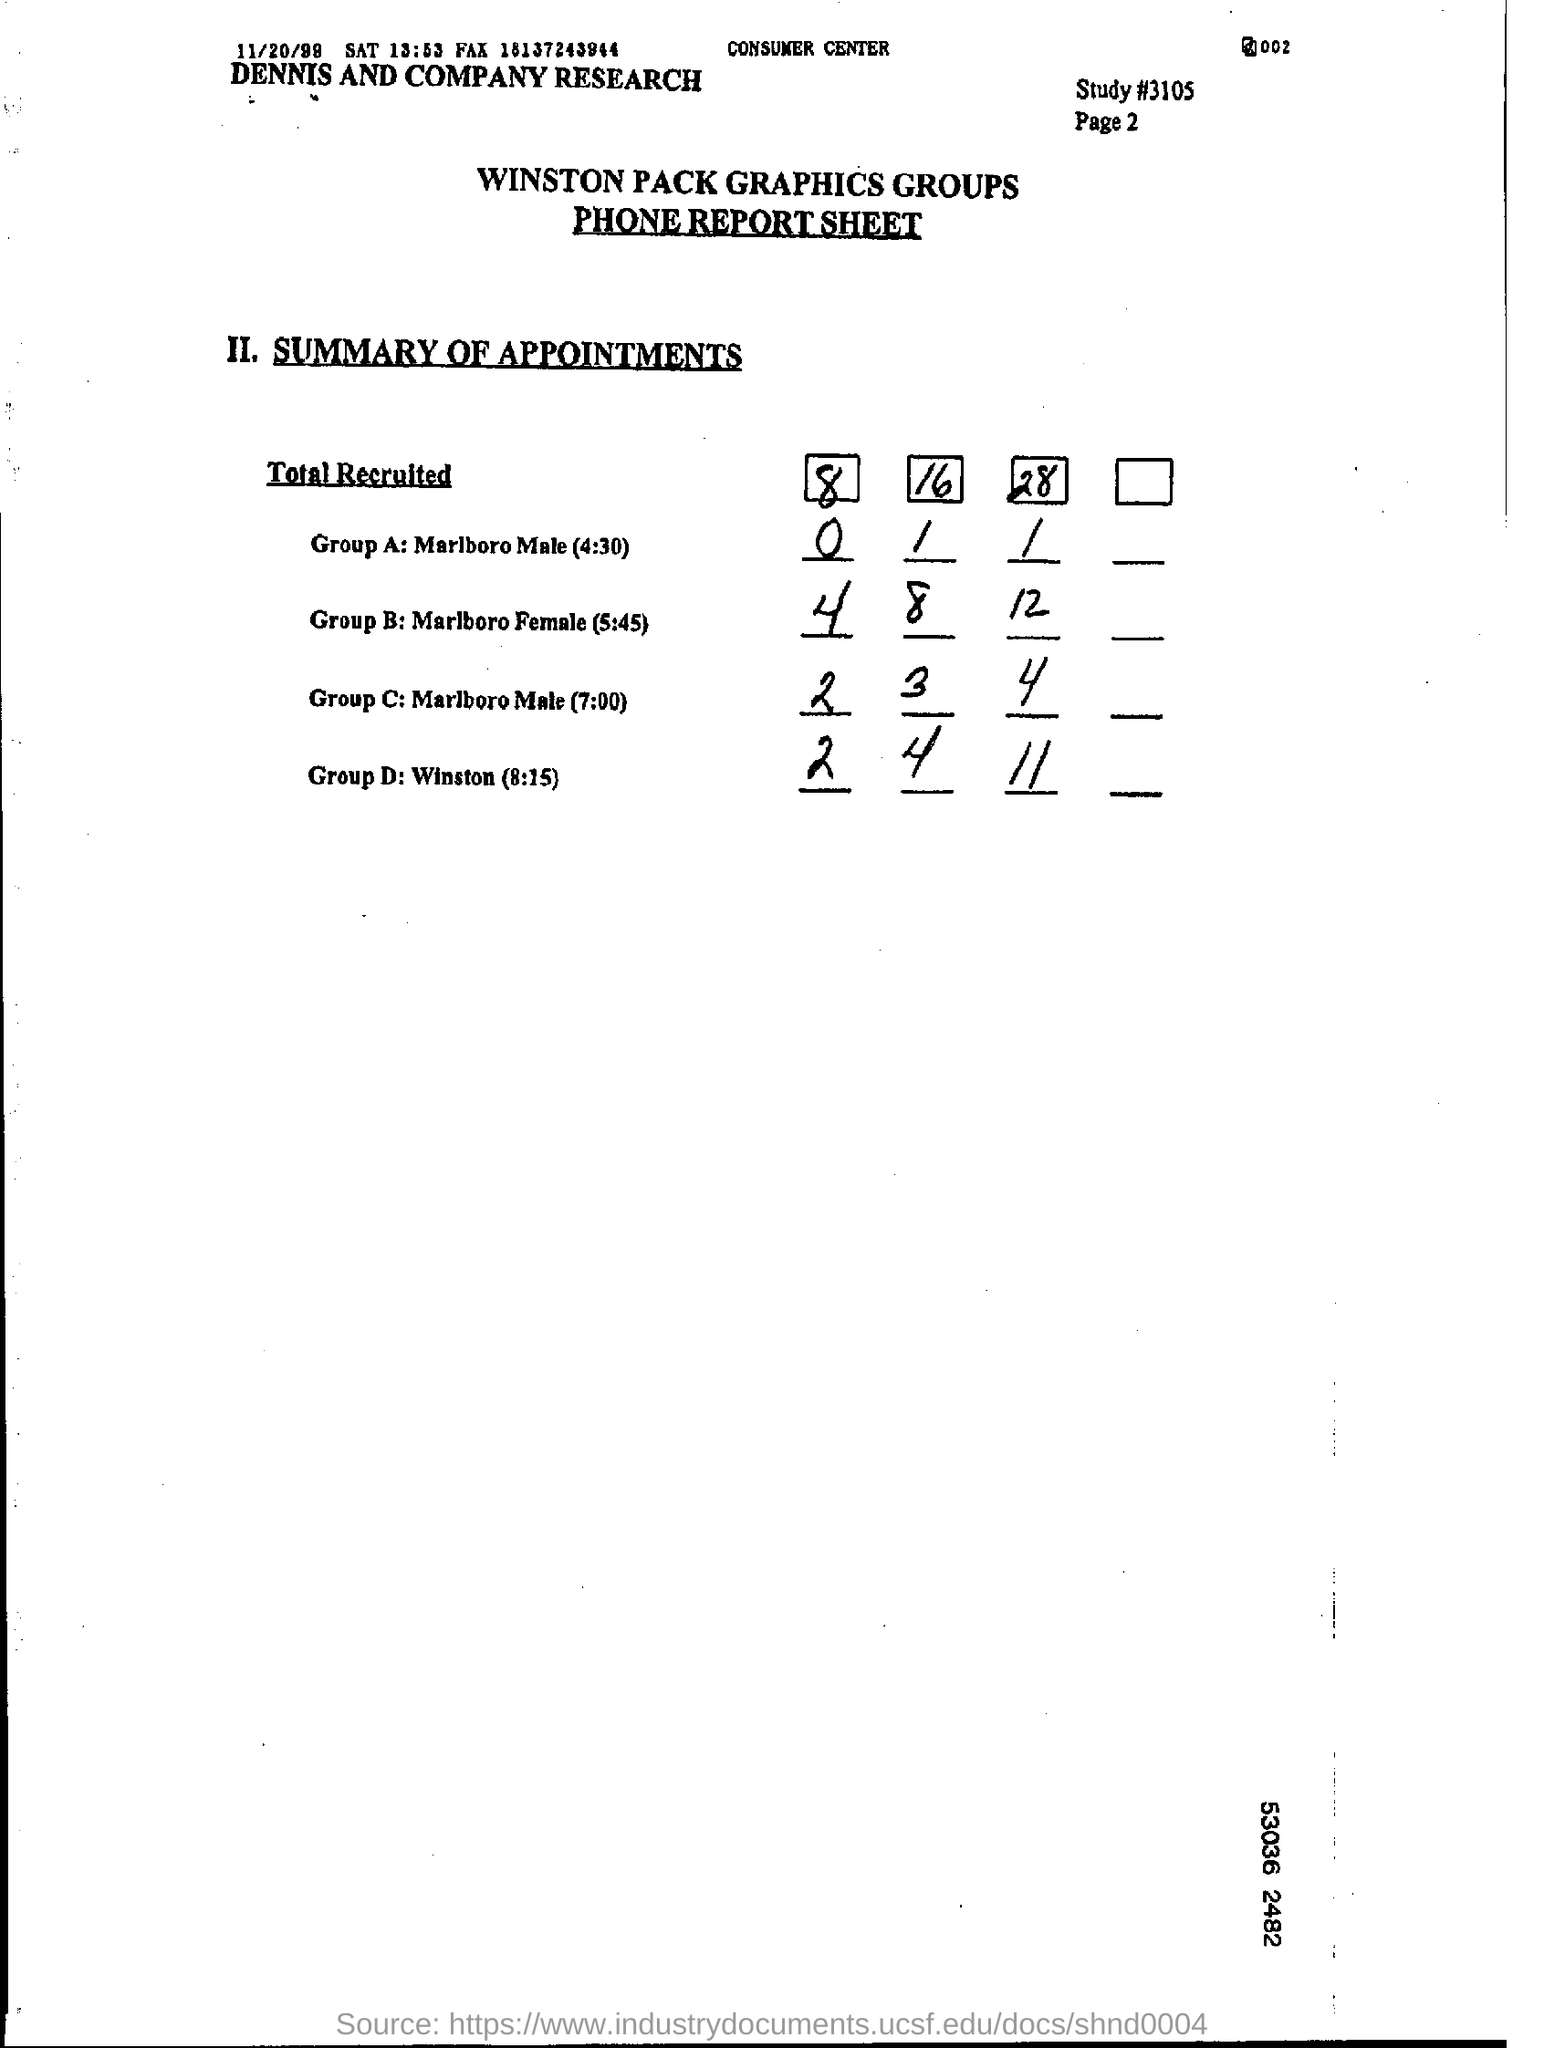What kind of report sheet?
Ensure brevity in your answer.  Phone report sheet. What is the name of groups?
Offer a terse response. WINSTON PACK GRAPHICS GROUPS. What is the code for the study ?
Keep it short and to the point. 3105. What is the name of group A under the title total recruited ?
Keep it short and to the point. Marlboro Male (4:30). What is the name of group D under the title total recruited?
Ensure brevity in your answer.  Winston (8:15). 